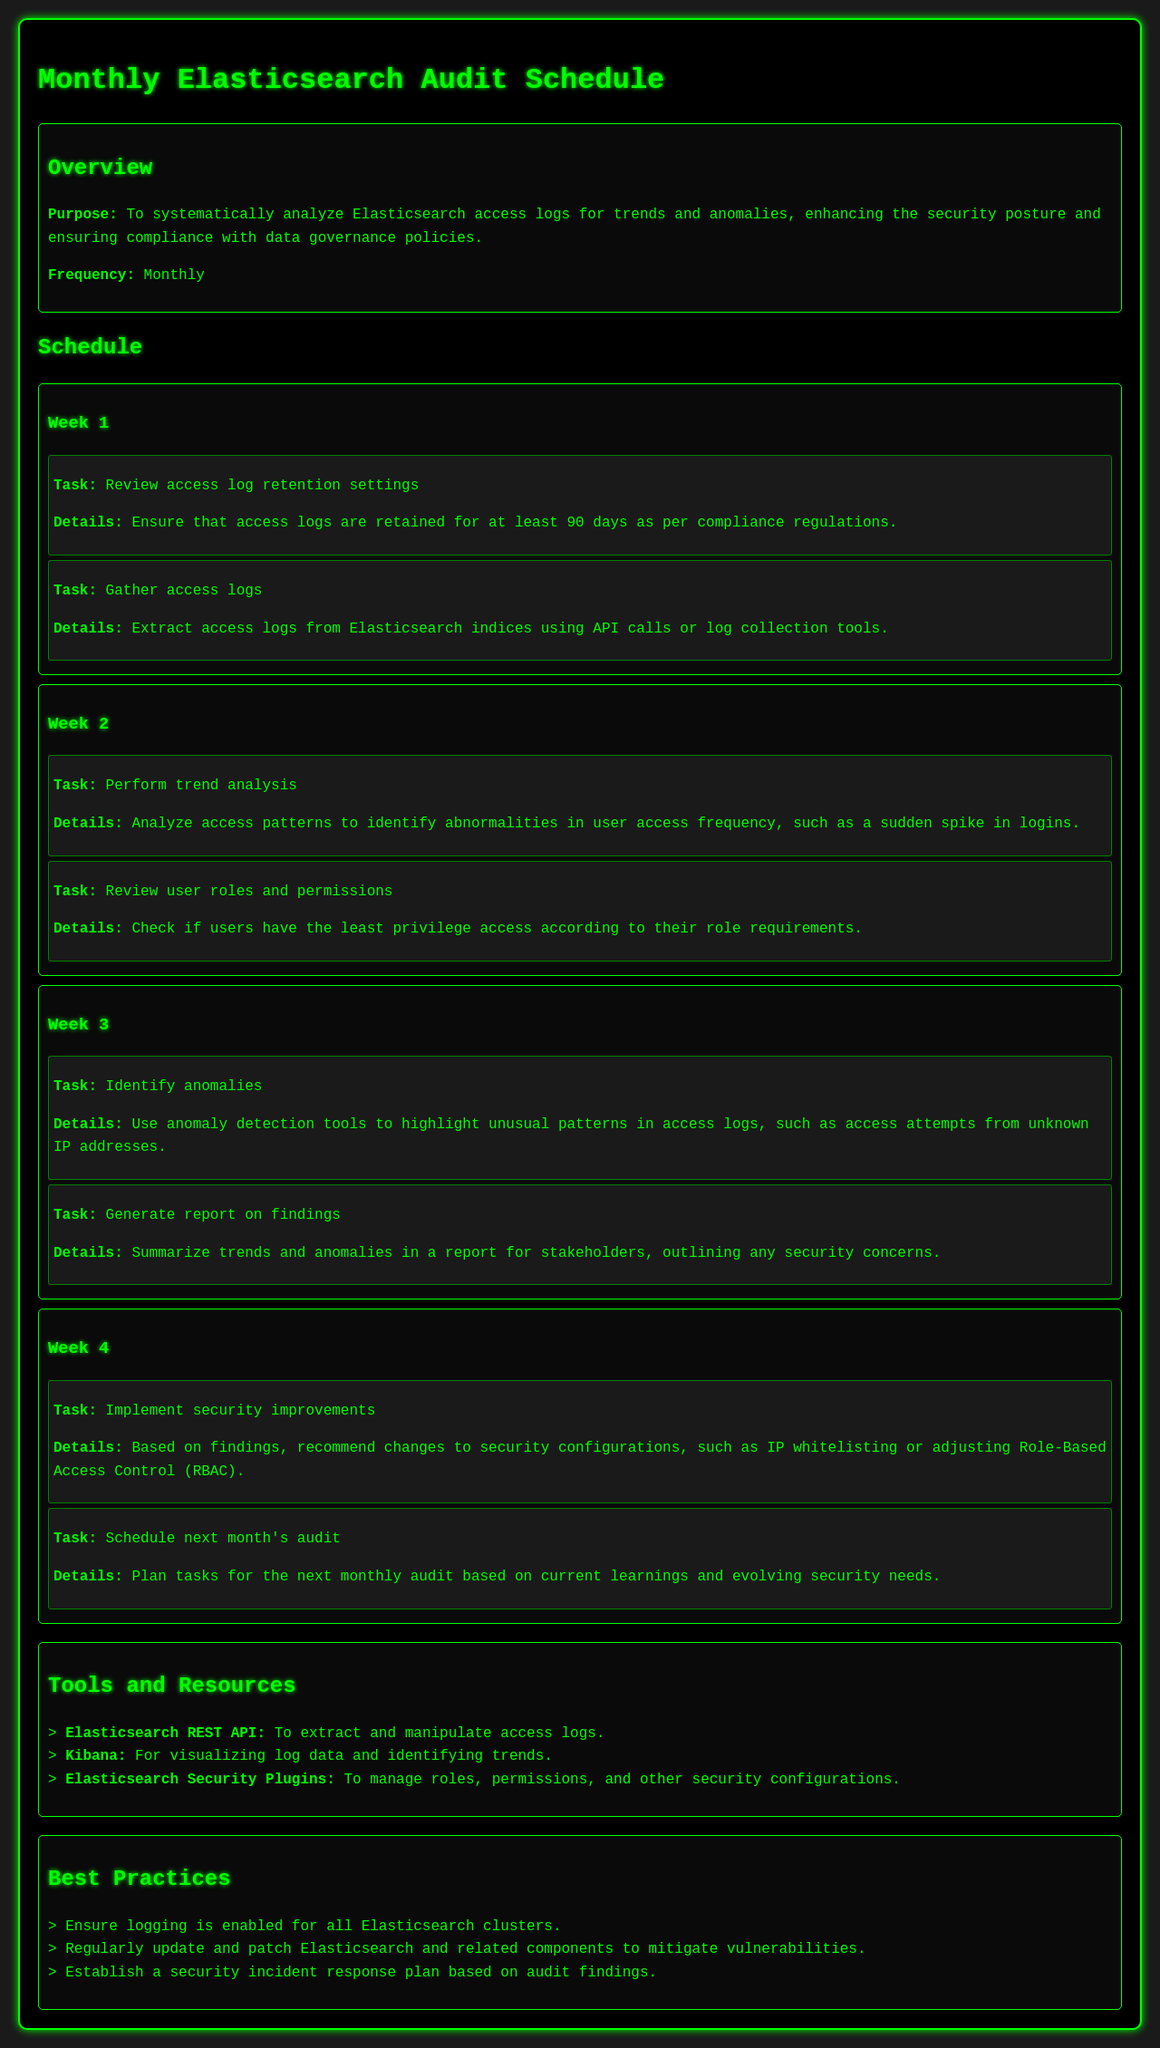What is the purpose of the audit schedule? The purpose is to systematically analyze Elasticsearch access logs for trends and anomalies, enhancing the security posture and ensuring compliance with data governance policies.
Answer: To systematically analyze Elasticsearch access logs for trends and anomalies How frequently is the audit conducted? The document states the frequency of the audit.
Answer: Monthly What is the task for Week 1 related to access logs? The task involves reviewing settings specifically about access logs retention.
Answer: Review access log retention settings How long should access logs be retained? This detail specifies a regulatory compliance requirement stated in the document.
Answer: 90 days What tool is mentioned for visualizing log data? The document lists specific tools and resources for the audit process.
Answer: Kibana What kind of analysis is performed in Week 2? This question relates to tasks outlined in the monthly schedule.
Answer: Trend analysis Which week involves generating a report on findings? This question asks for the specific week in which the related task occurs.
Answer: Week 3 What is a recommended best practice regarding updates? This addresses a specific recommendation presented in the best practices section.
Answer: Regularly update and patch Elasticsearch What is the task for Week 4 related to security improvements? This question targets the specific task designed to enhance security based on findings.
Answer: Implement security improvements 